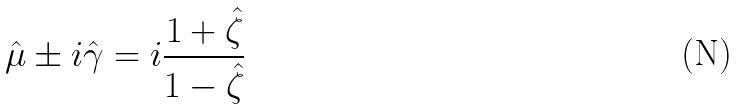<formula> <loc_0><loc_0><loc_500><loc_500>\hat { \mu } \pm i \hat { \gamma } = i \frac { 1 + \hat { \zeta } } { 1 - \hat { \zeta } }</formula> 